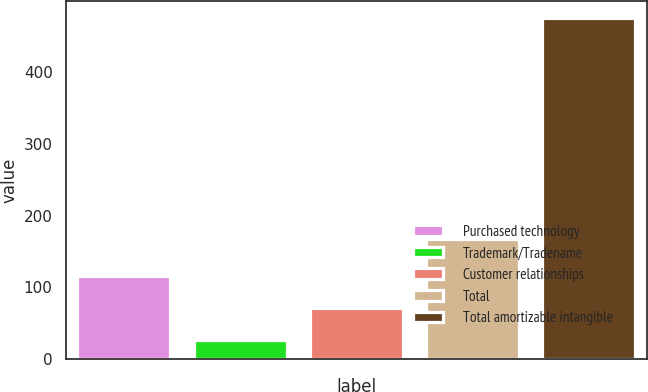<chart> <loc_0><loc_0><loc_500><loc_500><bar_chart><fcel>Purchased technology<fcel>Trademark/Tradename<fcel>Customer relationships<fcel>Total<fcel>Total amortizable intangible<nl><fcel>115.8<fcel>26<fcel>70.9<fcel>167<fcel>475<nl></chart> 